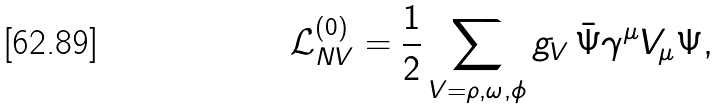Convert formula to latex. <formula><loc_0><loc_0><loc_500><loc_500>\mathcal { L } _ { N V } ^ { ( 0 ) } = \frac { 1 } { 2 } \sum _ { V = \rho , \omega , \phi } g _ { V } \, \bar { \Psi } \gamma ^ { \mu } V _ { \mu } \Psi ,</formula> 